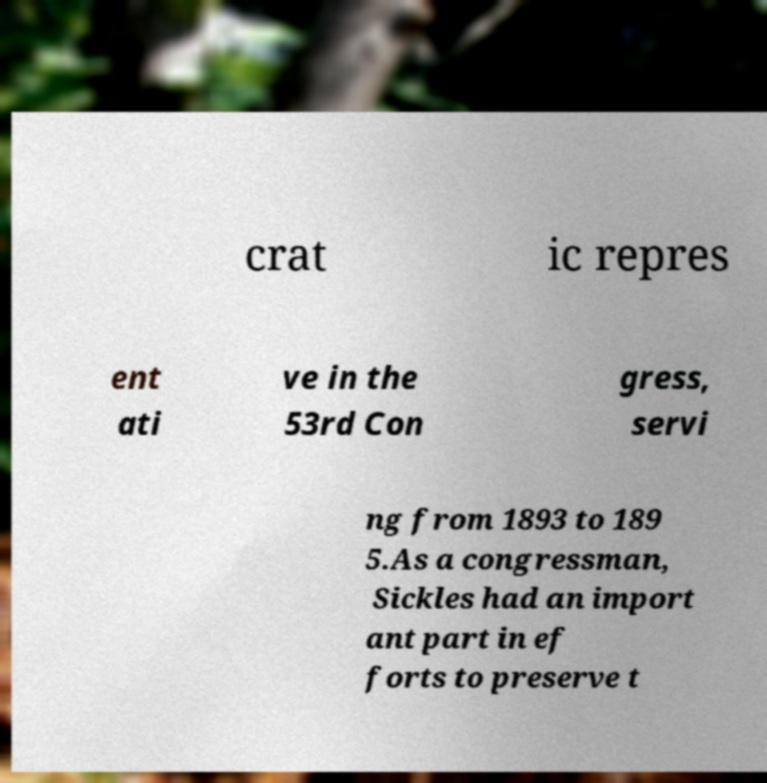Can you read and provide the text displayed in the image?This photo seems to have some interesting text. Can you extract and type it out for me? crat ic repres ent ati ve in the 53rd Con gress, servi ng from 1893 to 189 5.As a congressman, Sickles had an import ant part in ef forts to preserve t 